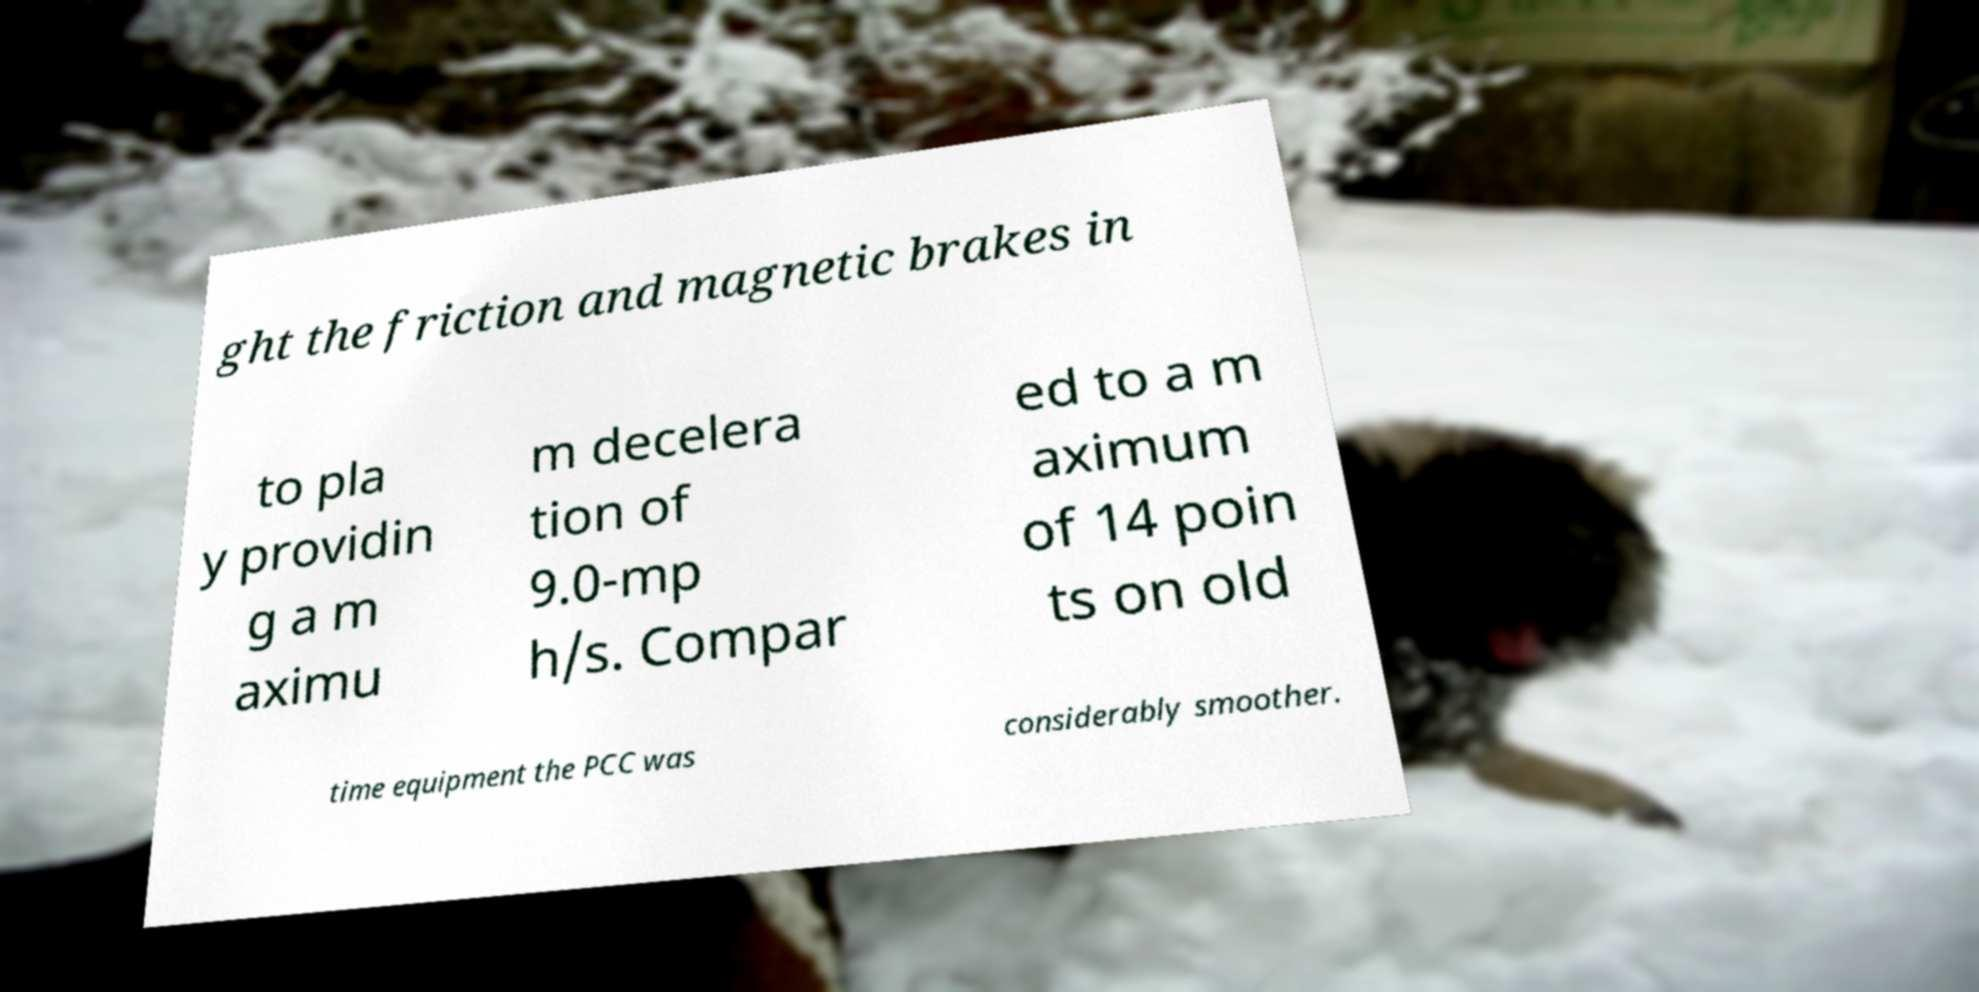Please identify and transcribe the text found in this image. ght the friction and magnetic brakes in to pla y providin g a m aximu m decelera tion of 9.0-mp h/s. Compar ed to a m aximum of 14 poin ts on old time equipment the PCC was considerably smoother. 